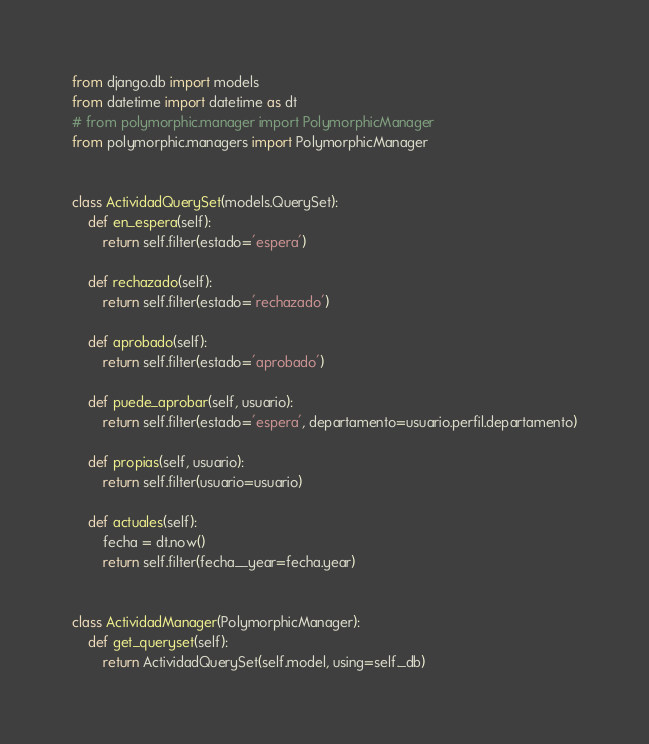<code> <loc_0><loc_0><loc_500><loc_500><_Python_>from django.db import models
from datetime import datetime as dt
# from polymorphic.manager import PolymorphicManager
from polymorphic.managers import PolymorphicManager


class ActividadQuerySet(models.QuerySet):
    def en_espera(self):
        return self.filter(estado='espera')

    def rechazado(self):
        return self.filter(estado='rechazado')

    def aprobado(self):
        return self.filter(estado='aprobado')

    def puede_aprobar(self, usuario):
        return self.filter(estado='espera', departamento=usuario.perfil.departamento)

    def propias(self, usuario):
        return self.filter(usuario=usuario)

    def actuales(self):
        fecha = dt.now()
        return self.filter(fecha__year=fecha.year)


class ActividadManager(PolymorphicManager):
    def get_queryset(self):
        return ActividadQuerySet(self.model, using=self._db)
</code> 